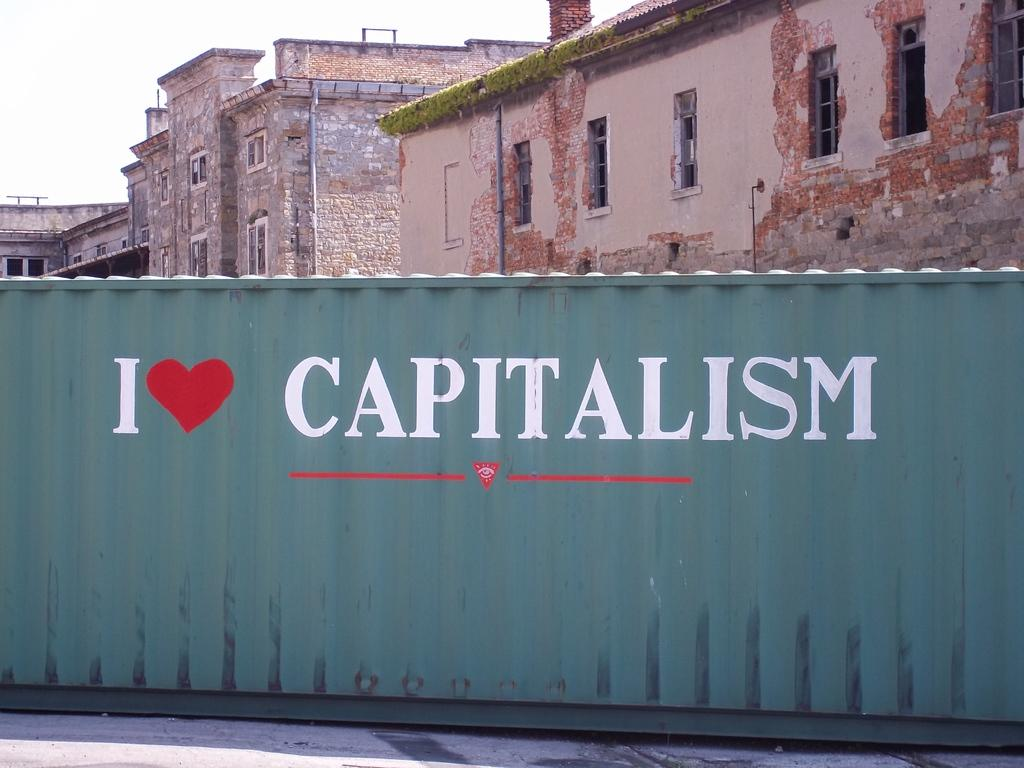What object is present in the image? There is a container in the image. What color is the container? The container is green in color. What message is written on the container? The phrase "I love capitalism" is written on the container. What can be seen in the background of the image? There are buildings in the background of the image. What type of substance is being used by the achiever in the image? There is no achiever present in the image, and therefore no substance use can be observed. 